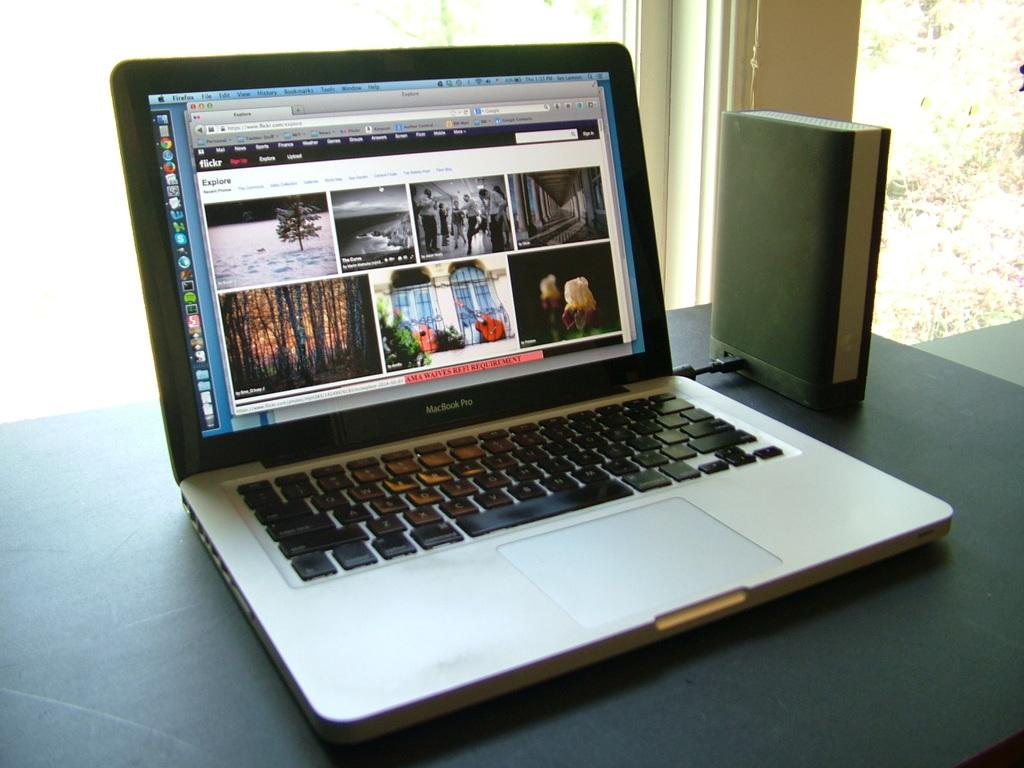<image>
Provide a brief description of the given image. Flickr Explore is the header of the web page of this open laptop. 